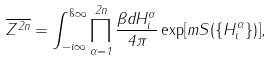<formula> <loc_0><loc_0><loc_500><loc_500>\overline { Z ^ { 2 n } } = \int _ { - i \infty } ^ { \i \infty } \prod _ { \alpha = 1 } ^ { 2 n } \frac { \beta d H _ { i } ^ { \alpha } } { 4 \pi } \exp [ m S ( \{ H _ { i } ^ { \alpha } \} ) ] ,</formula> 